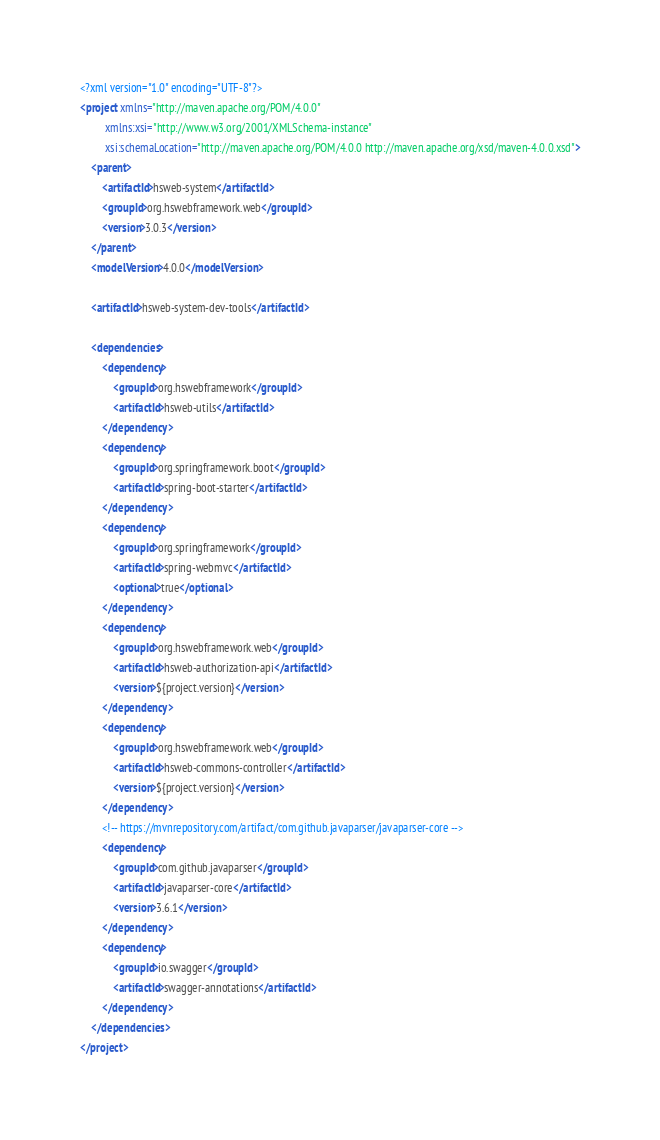<code> <loc_0><loc_0><loc_500><loc_500><_XML_><?xml version="1.0" encoding="UTF-8"?>
<project xmlns="http://maven.apache.org/POM/4.0.0"
         xmlns:xsi="http://www.w3.org/2001/XMLSchema-instance"
         xsi:schemaLocation="http://maven.apache.org/POM/4.0.0 http://maven.apache.org/xsd/maven-4.0.0.xsd">
    <parent>
        <artifactId>hsweb-system</artifactId>
        <groupId>org.hswebframework.web</groupId>
        <version>3.0.3</version>
    </parent>
    <modelVersion>4.0.0</modelVersion>

    <artifactId>hsweb-system-dev-tools</artifactId>

    <dependencies>
        <dependency>
            <groupId>org.hswebframework</groupId>
            <artifactId>hsweb-utils</artifactId>
        </dependency>
        <dependency>
            <groupId>org.springframework.boot</groupId>
            <artifactId>spring-boot-starter</artifactId>
        </dependency>
        <dependency>
            <groupId>org.springframework</groupId>
            <artifactId>spring-webmvc</artifactId>
            <optional>true</optional>
        </dependency>
        <dependency>
            <groupId>org.hswebframework.web</groupId>
            <artifactId>hsweb-authorization-api</artifactId>
            <version>${project.version}</version>
        </dependency>
        <dependency>
            <groupId>org.hswebframework.web</groupId>
            <artifactId>hsweb-commons-controller</artifactId>
            <version>${project.version}</version>
        </dependency>
        <!-- https://mvnrepository.com/artifact/com.github.javaparser/javaparser-core -->
        <dependency>
            <groupId>com.github.javaparser</groupId>
            <artifactId>javaparser-core</artifactId>
            <version>3.6.1</version>
        </dependency>
        <dependency>
            <groupId>io.swagger</groupId>
            <artifactId>swagger-annotations</artifactId>
        </dependency>
    </dependencies>
</project></code> 